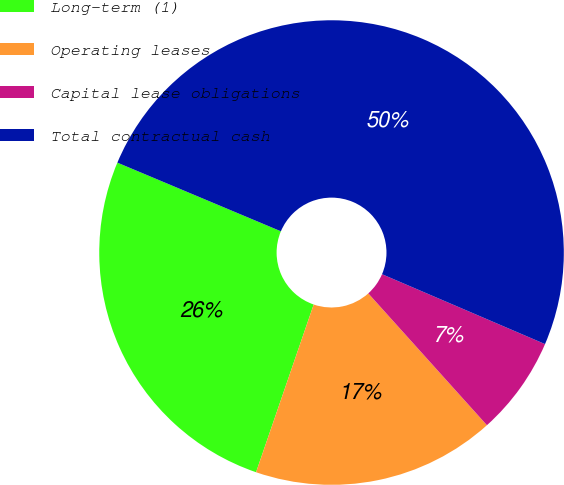Convert chart to OTSL. <chart><loc_0><loc_0><loc_500><loc_500><pie_chart><fcel>Long-term (1)<fcel>Operating leases<fcel>Capital lease obligations<fcel>Total contractual cash<nl><fcel>26.06%<fcel>16.93%<fcel>6.89%<fcel>50.12%<nl></chart> 